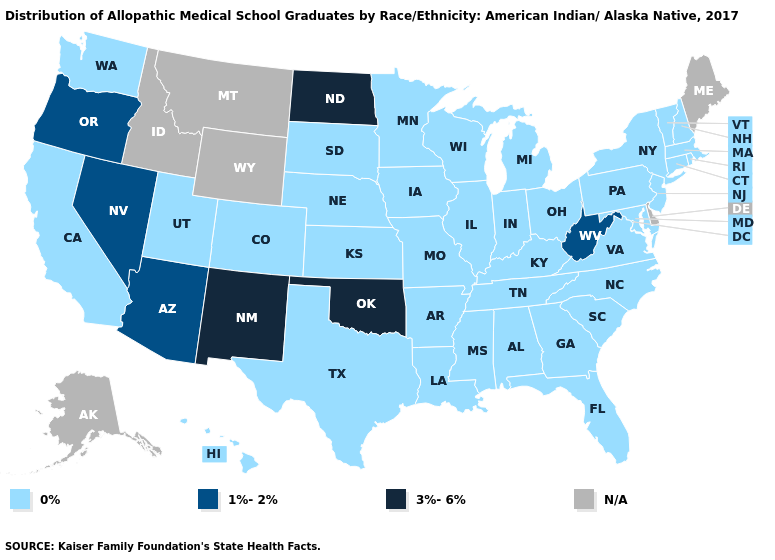What is the lowest value in the South?
Quick response, please. 0%. Name the states that have a value in the range 0%?
Quick response, please. Alabama, Arkansas, California, Colorado, Connecticut, Florida, Georgia, Hawaii, Illinois, Indiana, Iowa, Kansas, Kentucky, Louisiana, Maryland, Massachusetts, Michigan, Minnesota, Mississippi, Missouri, Nebraska, New Hampshire, New Jersey, New York, North Carolina, Ohio, Pennsylvania, Rhode Island, South Carolina, South Dakota, Tennessee, Texas, Utah, Vermont, Virginia, Washington, Wisconsin. Does Texas have the highest value in the South?
Answer briefly. No. What is the highest value in the USA?
Write a very short answer. 3%-6%. Which states have the lowest value in the USA?
Concise answer only. Alabama, Arkansas, California, Colorado, Connecticut, Florida, Georgia, Hawaii, Illinois, Indiana, Iowa, Kansas, Kentucky, Louisiana, Maryland, Massachusetts, Michigan, Minnesota, Mississippi, Missouri, Nebraska, New Hampshire, New Jersey, New York, North Carolina, Ohio, Pennsylvania, Rhode Island, South Carolina, South Dakota, Tennessee, Texas, Utah, Vermont, Virginia, Washington, Wisconsin. Among the states that border Arkansas , which have the lowest value?
Answer briefly. Louisiana, Mississippi, Missouri, Tennessee, Texas. Among the states that border Alabama , which have the highest value?
Keep it brief. Florida, Georgia, Mississippi, Tennessee. What is the value of North Dakota?
Give a very brief answer. 3%-6%. What is the value of Nebraska?
Keep it brief. 0%. Does Arkansas have the lowest value in the USA?
Keep it brief. Yes. How many symbols are there in the legend?
Keep it brief. 4. Name the states that have a value in the range N/A?
Quick response, please. Alaska, Delaware, Idaho, Maine, Montana, Wyoming. Name the states that have a value in the range 1%-2%?
Short answer required. Arizona, Nevada, Oregon, West Virginia. What is the lowest value in states that border New Mexico?
Quick response, please. 0%. Among the states that border Nevada , which have the highest value?
Give a very brief answer. Arizona, Oregon. 